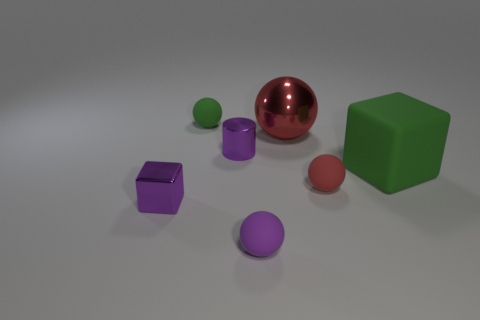What shape is the small shiny object that is the same color as the small cylinder?
Make the answer very short. Cube. Do the red metallic object and the purple rubber object have the same shape?
Provide a short and direct response. Yes. There is a matte sphere that is behind the shiny thing on the right side of the purple ball; is there a metallic sphere that is to the left of it?
Keep it short and to the point. No. How many other tiny metal cylinders have the same color as the small cylinder?
Provide a succinct answer. 0. There is a green object that is the same size as the purple ball; what is its shape?
Ensure brevity in your answer.  Sphere. Are there any small purple balls in front of the small purple sphere?
Ensure brevity in your answer.  No. Is the green cube the same size as the green sphere?
Give a very brief answer. No. There is a tiny matte object that is in front of the red matte ball; what shape is it?
Give a very brief answer. Sphere. Is there another green block that has the same size as the metal block?
Give a very brief answer. No. What material is the purple ball that is the same size as the purple metallic cylinder?
Your answer should be very brief. Rubber. 